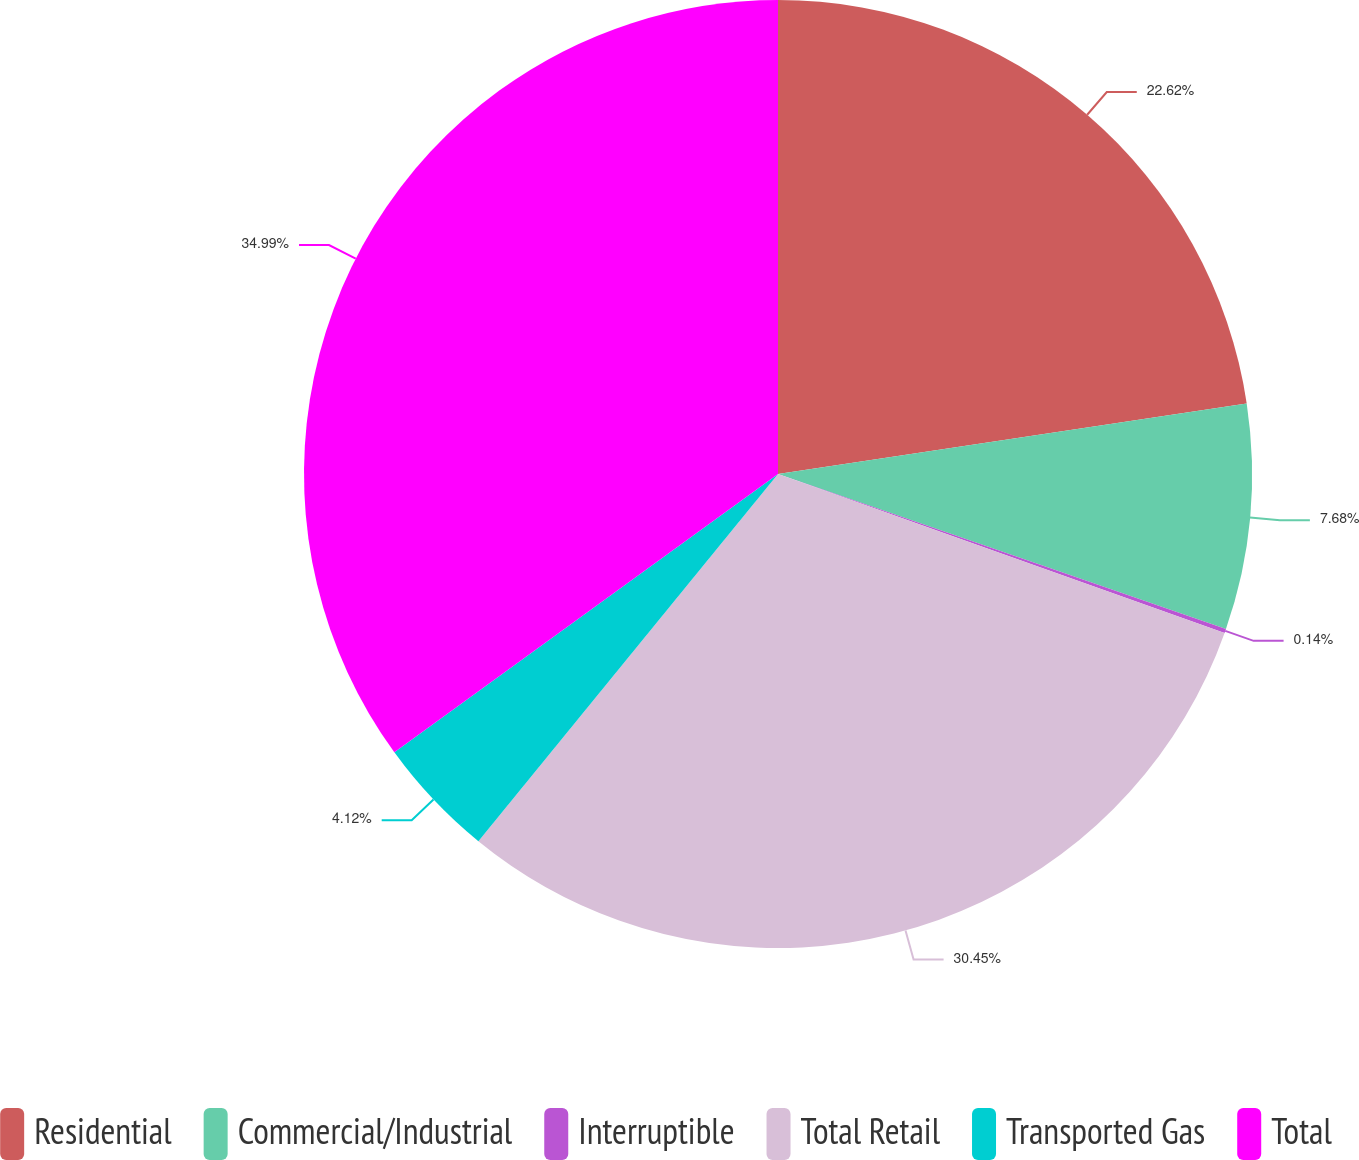<chart> <loc_0><loc_0><loc_500><loc_500><pie_chart><fcel>Residential<fcel>Commercial/Industrial<fcel>Interruptible<fcel>Total Retail<fcel>Transported Gas<fcel>Total<nl><fcel>22.62%<fcel>7.68%<fcel>0.14%<fcel>30.45%<fcel>4.12%<fcel>34.99%<nl></chart> 